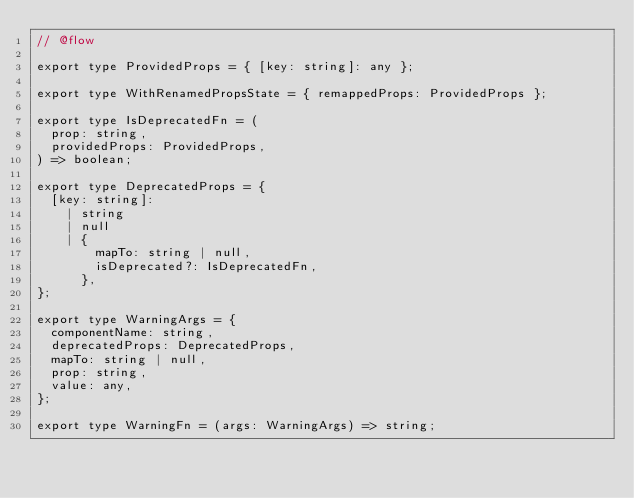<code> <loc_0><loc_0><loc_500><loc_500><_JavaScript_>// @flow

export type ProvidedProps = { [key: string]: any };

export type WithRenamedPropsState = { remappedProps: ProvidedProps };

export type IsDeprecatedFn = (
  prop: string,
  providedProps: ProvidedProps,
) => boolean;

export type DeprecatedProps = {
  [key: string]:
    | string
    | null
    | {
        mapTo: string | null,
        isDeprecated?: IsDeprecatedFn,
      },
};

export type WarningArgs = {
  componentName: string,
  deprecatedProps: DeprecatedProps,
  mapTo: string | null,
  prop: string,
  value: any,
};

export type WarningFn = (args: WarningArgs) => string;
</code> 